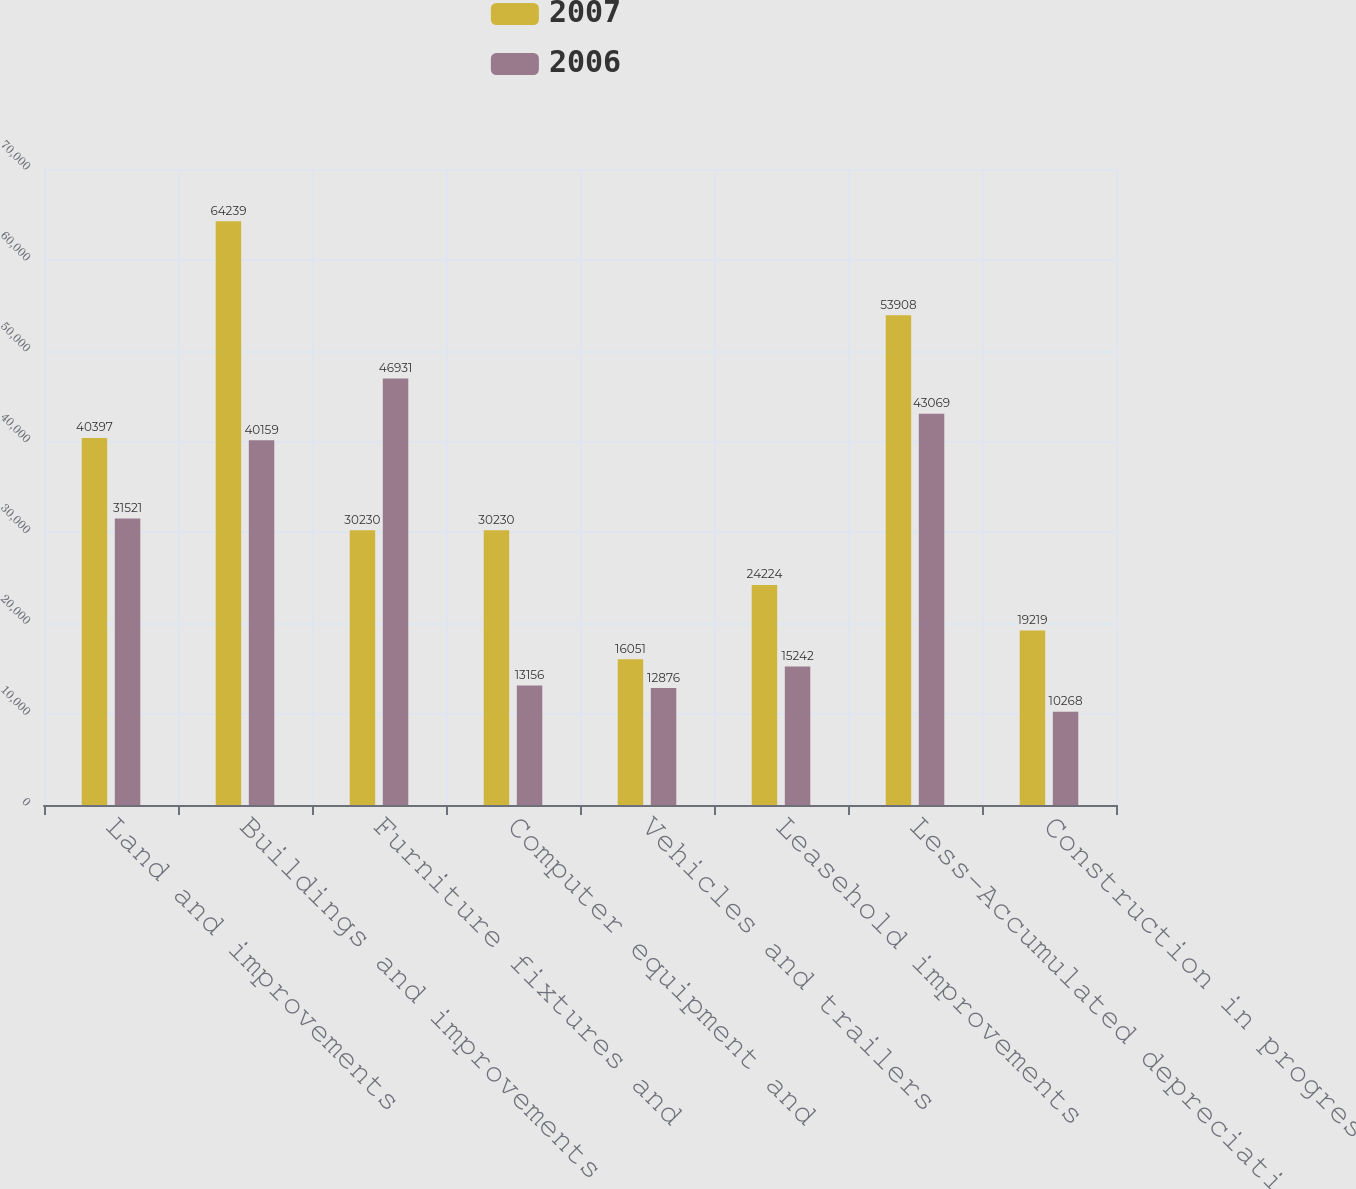Convert chart. <chart><loc_0><loc_0><loc_500><loc_500><stacked_bar_chart><ecel><fcel>Land and improvements<fcel>Buildings and improvements<fcel>Furniture fixtures and<fcel>Computer equipment and<fcel>Vehicles and trailers<fcel>Leasehold improvements<fcel>Less-Accumulated depreciation<fcel>Construction in progress<nl><fcel>2007<fcel>40397<fcel>64239<fcel>30230<fcel>30230<fcel>16051<fcel>24224<fcel>53908<fcel>19219<nl><fcel>2006<fcel>31521<fcel>40159<fcel>46931<fcel>13156<fcel>12876<fcel>15242<fcel>43069<fcel>10268<nl></chart> 